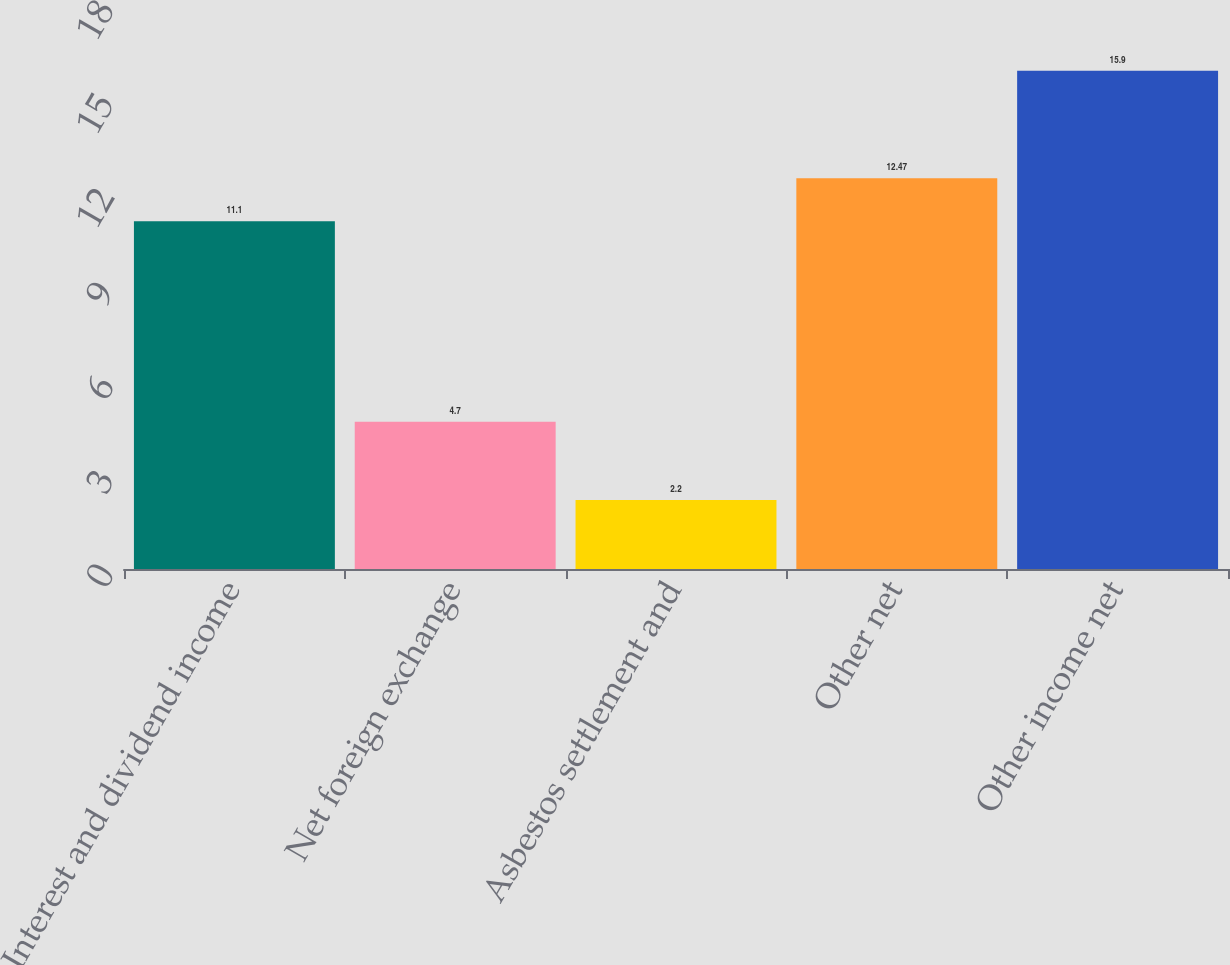Convert chart. <chart><loc_0><loc_0><loc_500><loc_500><bar_chart><fcel>Interest and dividend income<fcel>Net foreign exchange<fcel>Asbestos settlement and<fcel>Other net<fcel>Other income net<nl><fcel>11.1<fcel>4.7<fcel>2.2<fcel>12.47<fcel>15.9<nl></chart> 